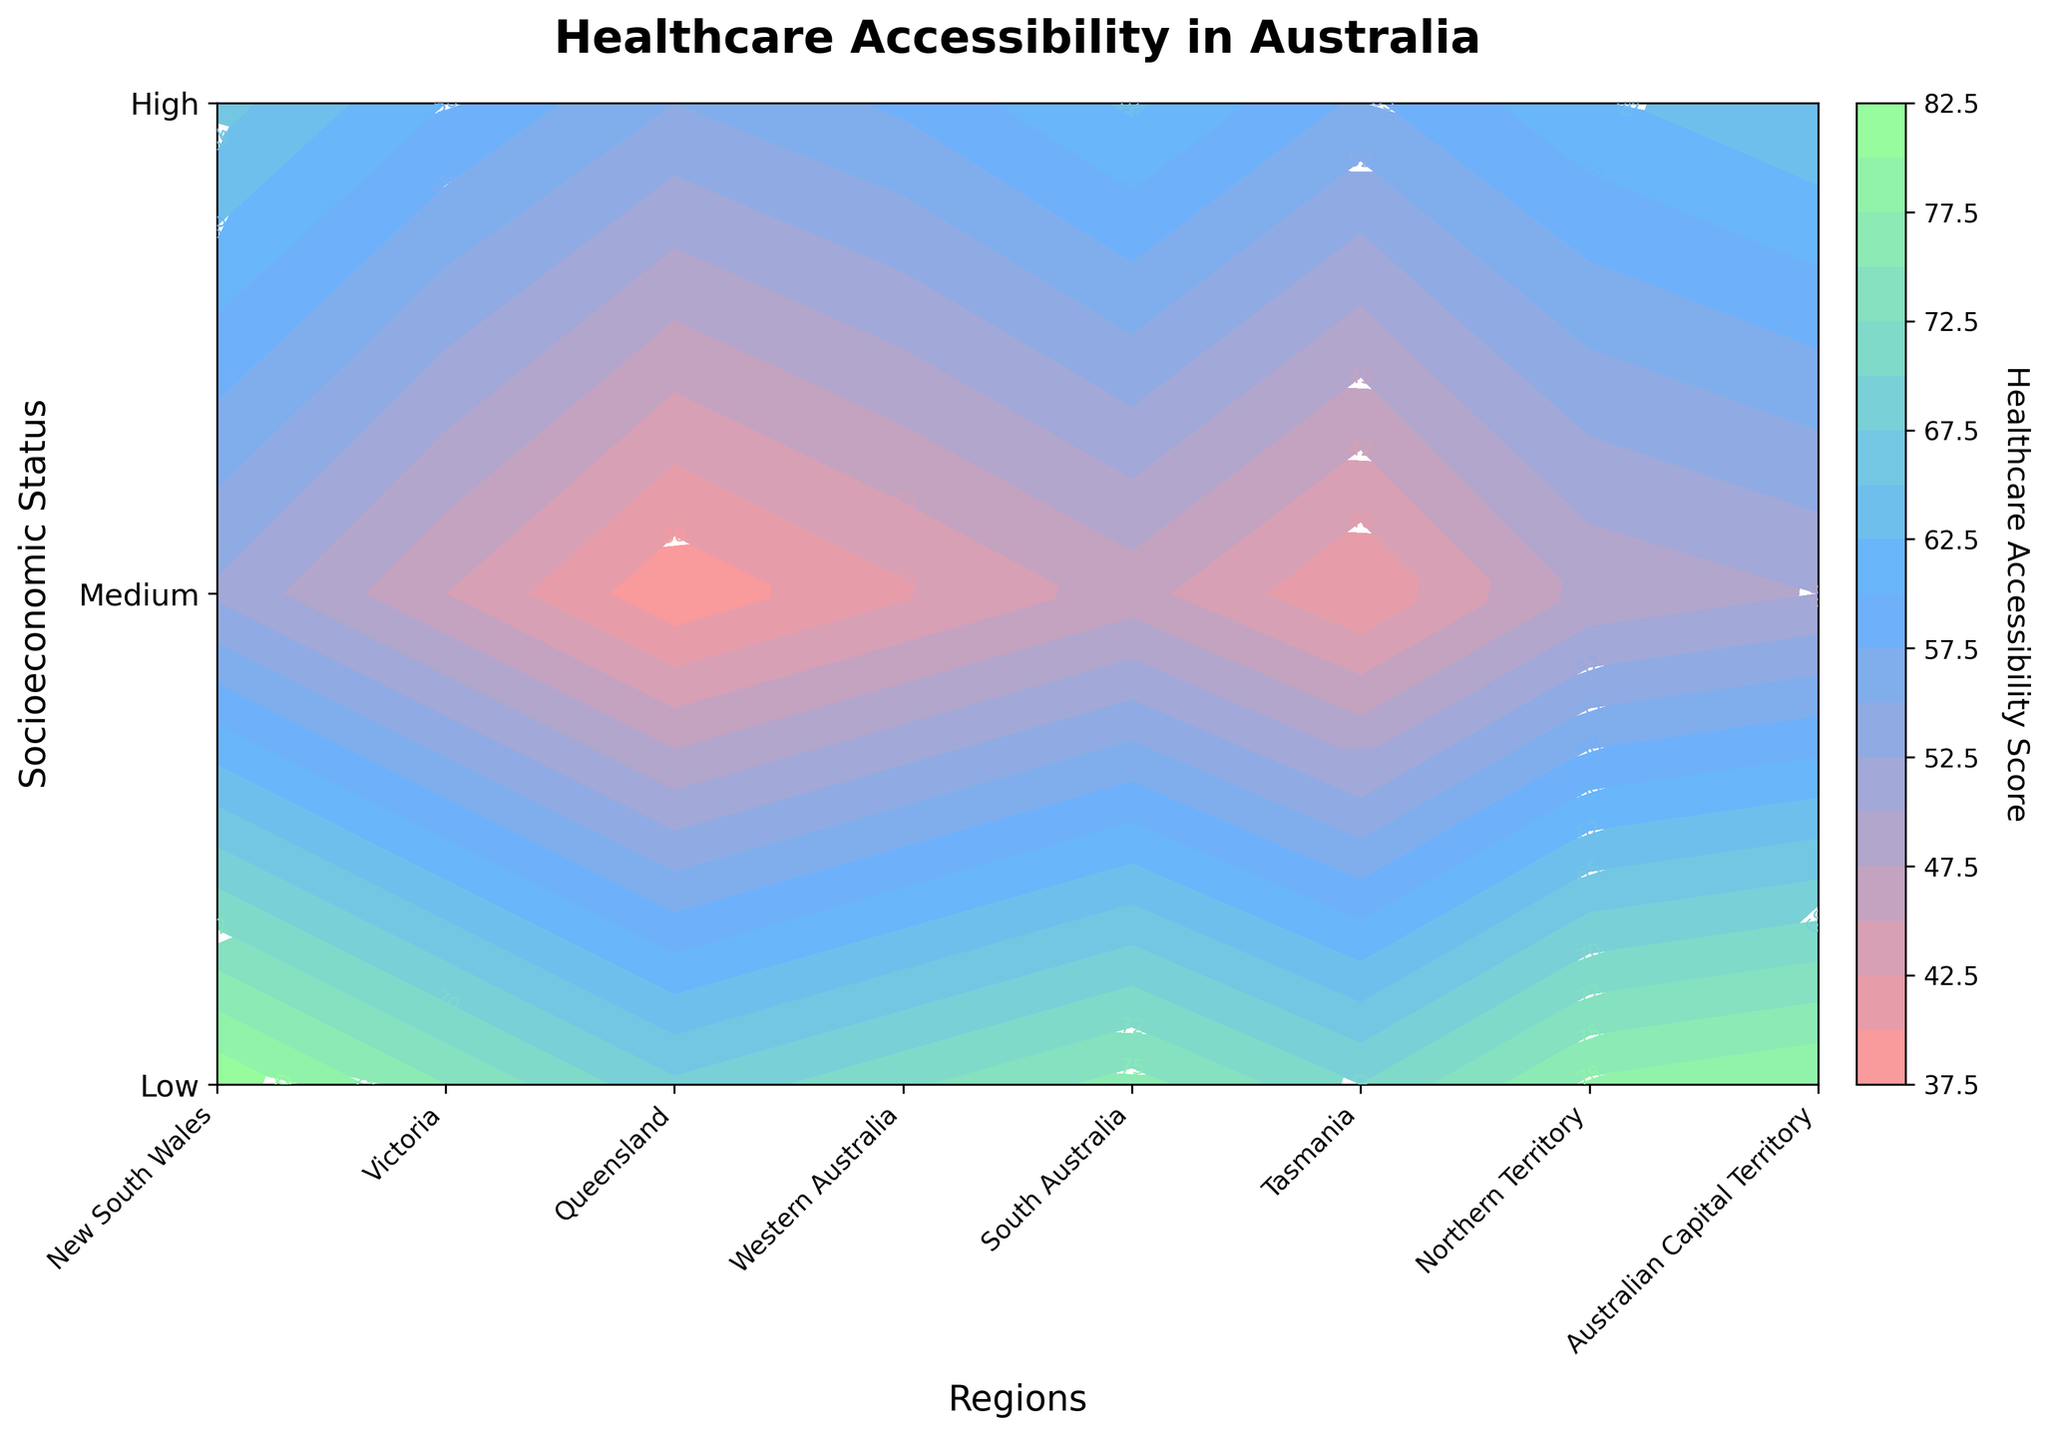Which region has the highest healthcare accessibility score for low socioeconomic status? Look at the "Low" socioeconomic status row and identify the highest score among the regions. The highest score is associated with the Australian Capital Territory.
Answer: Australian Capital Territory What's the average healthcare accessibility score for medium socioeconomic status across all regions? Sum up the healthcare accessibility scores for "Medium" socioeconomic status across all regions: 60 + 62 + 58 + 65 + 63 + 57 + 55 + 66, which equals 486. Then, divide by the number of regions (8): 486 / 8 = 60.75.
Answer: 60.75 Which socioeconomic status group has the largest range of healthcare accessibility scores? Calculate the range (highest score - lowest score) for each socioeconomic status group. Low: 52 - 38 = 14, Medium: 66 - 55 = 11, High: 82 - 68 = 14. Both Low and High groups have a range of 14.
Answer: Low and High In which region is the increase in healthcare accessibility score from low to medium socioeconomic status the smallest? Calculate the difference between medium and low scores for each region. New South Wales: 60 - 45 = 15, Victoria: 62 - 48 = 14, Queensland: 58 - 42 = 16, Western Australia: 65 - 50 = 15, South Australia: 63 - 46 = 17, Tasmania: 57 - 40 = 17, Northern Territory: 55 - 38 = 17, Australian Capital Territory: 66 - 52 = 14. Victoria and Australian Capital Territory both have the smallest increase of 14.
Answer: Victoria and Australian Capital Territory What is the median healthcare accessibility score for high socioeconomic status? List the scores for "High" socioeconomic status: 75, 78, 72, 80, 76, 70, 68, 82. Order them: 68, 70, 72, 75, 76, 78, 80, 82. The median score is the average of the 4th and 5th elements: (75 + 76) / 2 = 75.5.
Answer: 75.5 Which socioeconomic status group shows the most uniform healthcare accessibility across all regions? Compare the scores within each socioeconomic status group. Low: 45, 48, 42, 50, 46, 40, 38, 52 shows variability. Medium: 60, 62, 58, 65, 63, 57, 55, 66 shows variability. High: 75, 78, 72, 80, 76, 70, 68, 82 shows variability. Mathematically, calculate variance if needed but visually, none seem uniform, Medium shows the least interquartile range.
Answer: Medium Which region has the most significant disparity in healthcare accessibility between low and high socioeconomic groups? Calculate the difference between high and low scores for each region. New South Wales: 75 - 45 = 30, Victoria: 78 - 48 = 30, Queensland: 72 - 42 = 30, Western Australia: 80 - 50 = 30, South Australia: 76 - 46 = 30, Tasmania: 70 - 40 = 30, Northern Territory: 68 - 38 = 30, Australian Capital Territory: 82 - 52 = 30. All regions exhibit the same disparity of 30.
Answer: All Regions (with disparity of 30) What is the highest healthcare accessibility score in Australia according to the plot? Identify the highest value among all the scores shown in the contour plot. The highest score present is 82 in the Australian Capital Territory for high socioeconomic status.
Answer: 82 